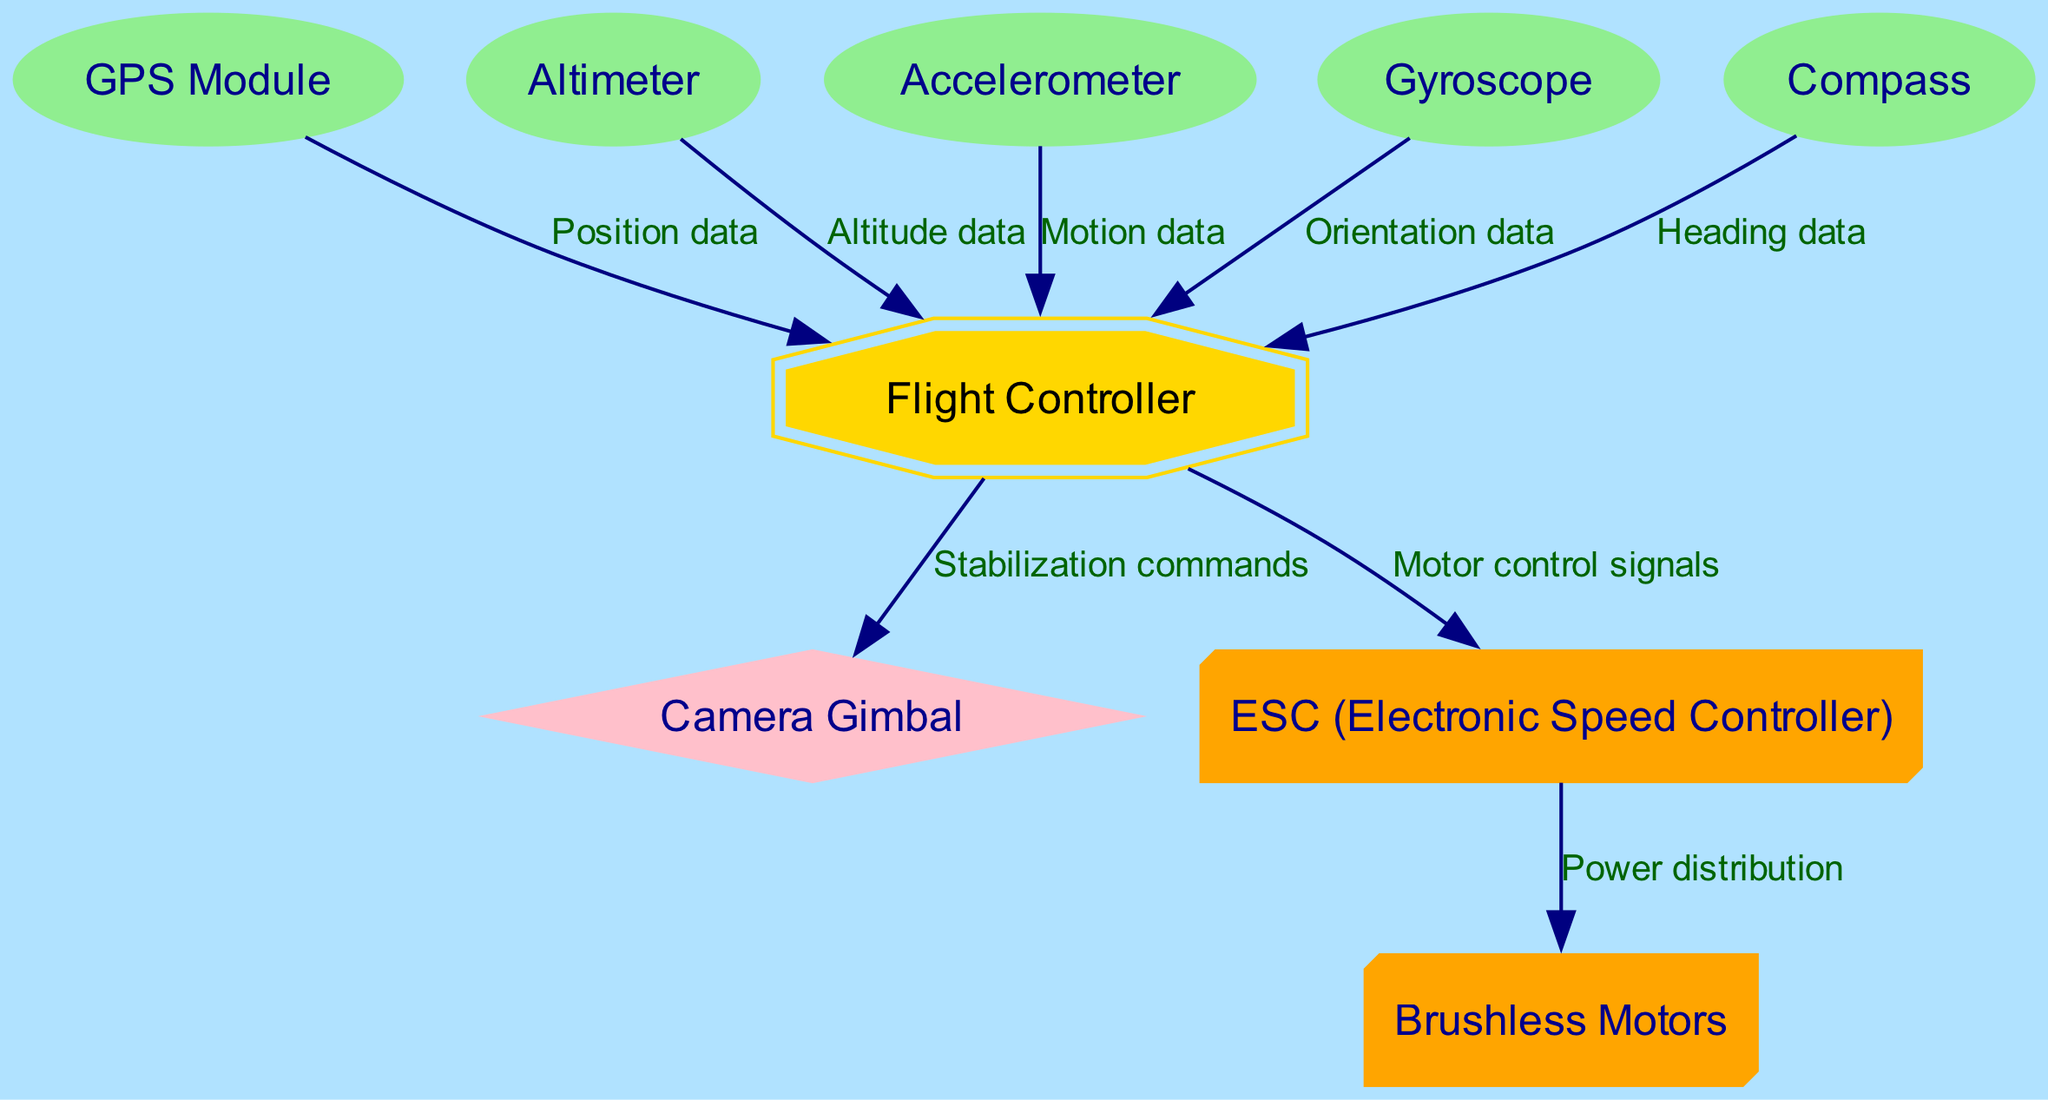What is the main component in charge of processing sensor data? The main component responsible for processing sensor data is the 'Flight Controller', as it connects with all sensor modules and processes their output data.
Answer: Flight Controller How many sensors are connected to the Flight Controller? The diagram shows five sensors directly connected to the Flight Controller: GPS Module, Altimeter, Accelerometer, Gyroscope, and Compass.
Answer: Five What data does the GPS Module provide to the Flight Controller? The GPS Module provides 'Position data' to the Flight Controller, which is crucial for navigation and control of the drone's flight path.
Answer: Position data Which component receives motor control signals from the Flight Controller? The component that receives motor control signals from the Flight Controller is the 'ESC (Electronic Speed Controller)', which then relays power to the Brushless Motors.
Answer: ESC (Electronic Speed Controller) What is the relationship between the ESC and Brushless Motors? The relationship is that the ESC is responsible for providing 'Power distribution' to the Brushless Motors, which allows them to function during flight.
Answer: Power distribution Which sensor provides data regarding the drone's altitude? The sensor that provides information on the drone's altitude is the 'Altimeter', which measures the height of the drone above ground level.
Answer: Altimeter Describe the type of commands sent from the Flight Controller to the Camera Gimbal. The Flight Controller sends 'Stabilization commands' to the Camera Gimbal to ensure it remains steady during flight, which is crucial for capturing stable images and video.
Answer: Stabilization commands How does the Gyroscope contribute to the Flight Controller's functionality? The Gyroscope contributes by providing 'Orientation data', which helps the Flight Controller maintain stable flight and navigate changes in orientation.
Answer: Orientation data What shape represents the Flight Controller in the diagram? The Flight Controller is depicted as a 'double octagon', which distinguishes it from other components visually in the schematic.
Answer: double octagon 